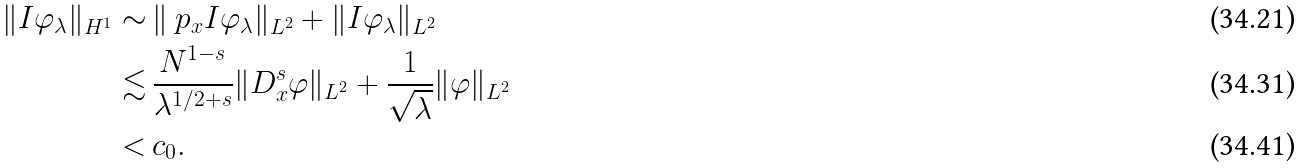<formula> <loc_0><loc_0><loc_500><loc_500>\| I \varphi _ { \lambda } \| _ { H ^ { 1 } } \sim & \, \| \ p _ { x } I \varphi _ { \lambda } \| _ { L ^ { 2 } } + \| I \varphi _ { \lambda } \| _ { L ^ { 2 } } \\ \lesssim & \, \frac { N ^ { 1 - s } } { \lambda ^ { 1 / 2 + s } } \| D _ { x } ^ { s } \varphi \| _ { L ^ { 2 } } + \frac { 1 } { \sqrt { \lambda } } \| \varphi \| _ { L ^ { 2 } } \\ < & \, c _ { 0 } .</formula> 